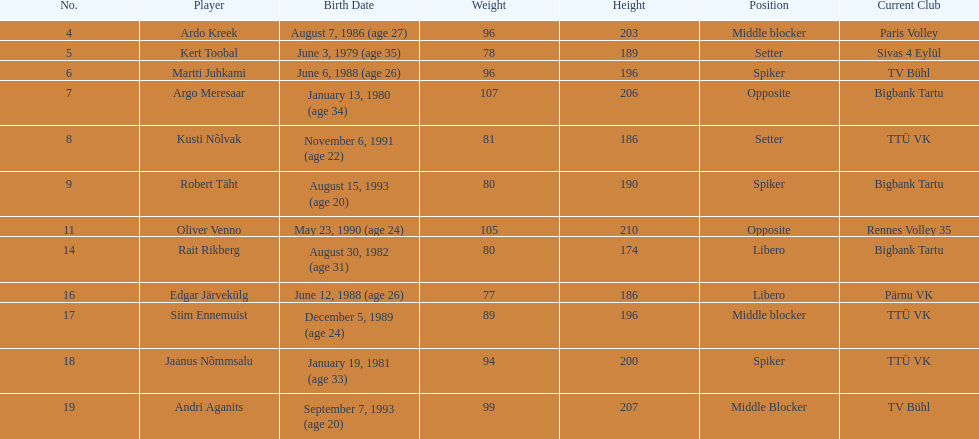Which players played the same position as ardo kreek? Siim Ennemuist, Andri Aganits. 